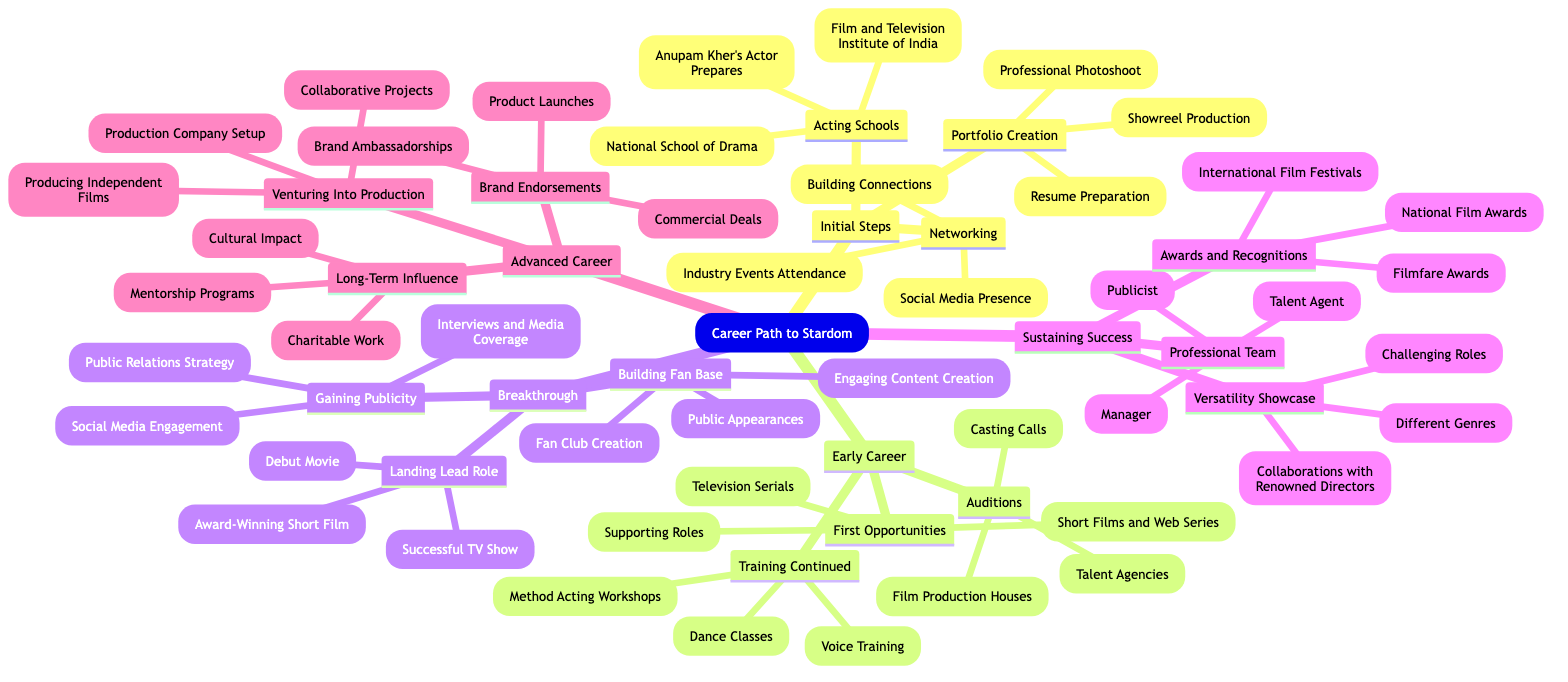What are the three main areas in the initial steps? The three main areas in the initial steps are "Acting Schools," "Portfolio Creation," and "Networking." Each of these areas contains specific actions and resources needed to kickstart a career in acting.
Answer: Acting Schools, Portfolio Creation, Networking How many nodes are there in the "Early Career" section? The "Early Career" section contains three main nodes: "Auditions," "First Opportunities," and "Training Continued." Counting these nodes gives a total of three.
Answer: 3 What type of roles should one aim for in "First Opportunities"? In "First Opportunities," one should aim for "Supporting Roles," "Television Serials," and "Short Films and Web Series." This indicates the various avenues available for newcomers to gain initial experience.
Answer: Supporting Roles, Television Serials, Short Films and Web Series What are two ways to gain publicity in the "Breakthrough" phase? Two ways to gain publicity in the "Breakthrough" phase are "Interviews and Media Coverage" and "Social Media Engagement." These strategies help to increase visibility and public recognition.
Answer: Interviews and Media Coverage, Social Media Engagement What does the "Professional Team" focus on in the "Sustaining Success" phase? The "Professional Team" in the "Sustaining Success" phase includes roles like "Talent Agent," "Publicist," and "Manager." These professionals play crucial roles in managing an actor's career and public image.
Answer: Talent Agent, Publicist, Manager What does "Venturing Into Production" lead to in the "Advanced Career"? "Venturing Into Production" can lead to a "Production Company Setup," producing "Independent Films," and engaging in "Collaborative Projects," expanding an actor's influence in the industry.
Answer: Production Company Setup, Producing Independent Films, Collaborative Projects How can an actor build a fan base during the "Breakthrough"? An actor can build a fan base during the "Breakthrough" phase by creating "Fan Club Creation," making "Public Appearances," and sharing "Engaging Content Creation." These activities connect the actor with their audience.
Answer: Fan Club Creation, Public Appearances, Engaging Content Creation What are two types of awards in the "Sustaining Success" category? Two types of awards in the "Sustaining Success" category include "Filmfare Awards" and "National Film Awards." Winning these awards can significantly enhance an actor's reputation and career.
Answer: Filmfare Awards, National Film Awards How does "Charitable Work" relate to "Long-Term Influence"? "Charitable Work" is linked to "Long-Term Influence" as it contributes to an actor's legacy and cultural impact. This involvement can enhance their public image and influence beyond acting.
Answer: Charitable Work What essential training should one continue in "Early Career"? In the "Early Career," essential training includes "Dance Classes," "Voice Training," and "Method Acting Workshops." These disciplines help enhance performance skills and versatility as an actor.
Answer: Dance Classes, Voice Training, Method Acting Workshops 